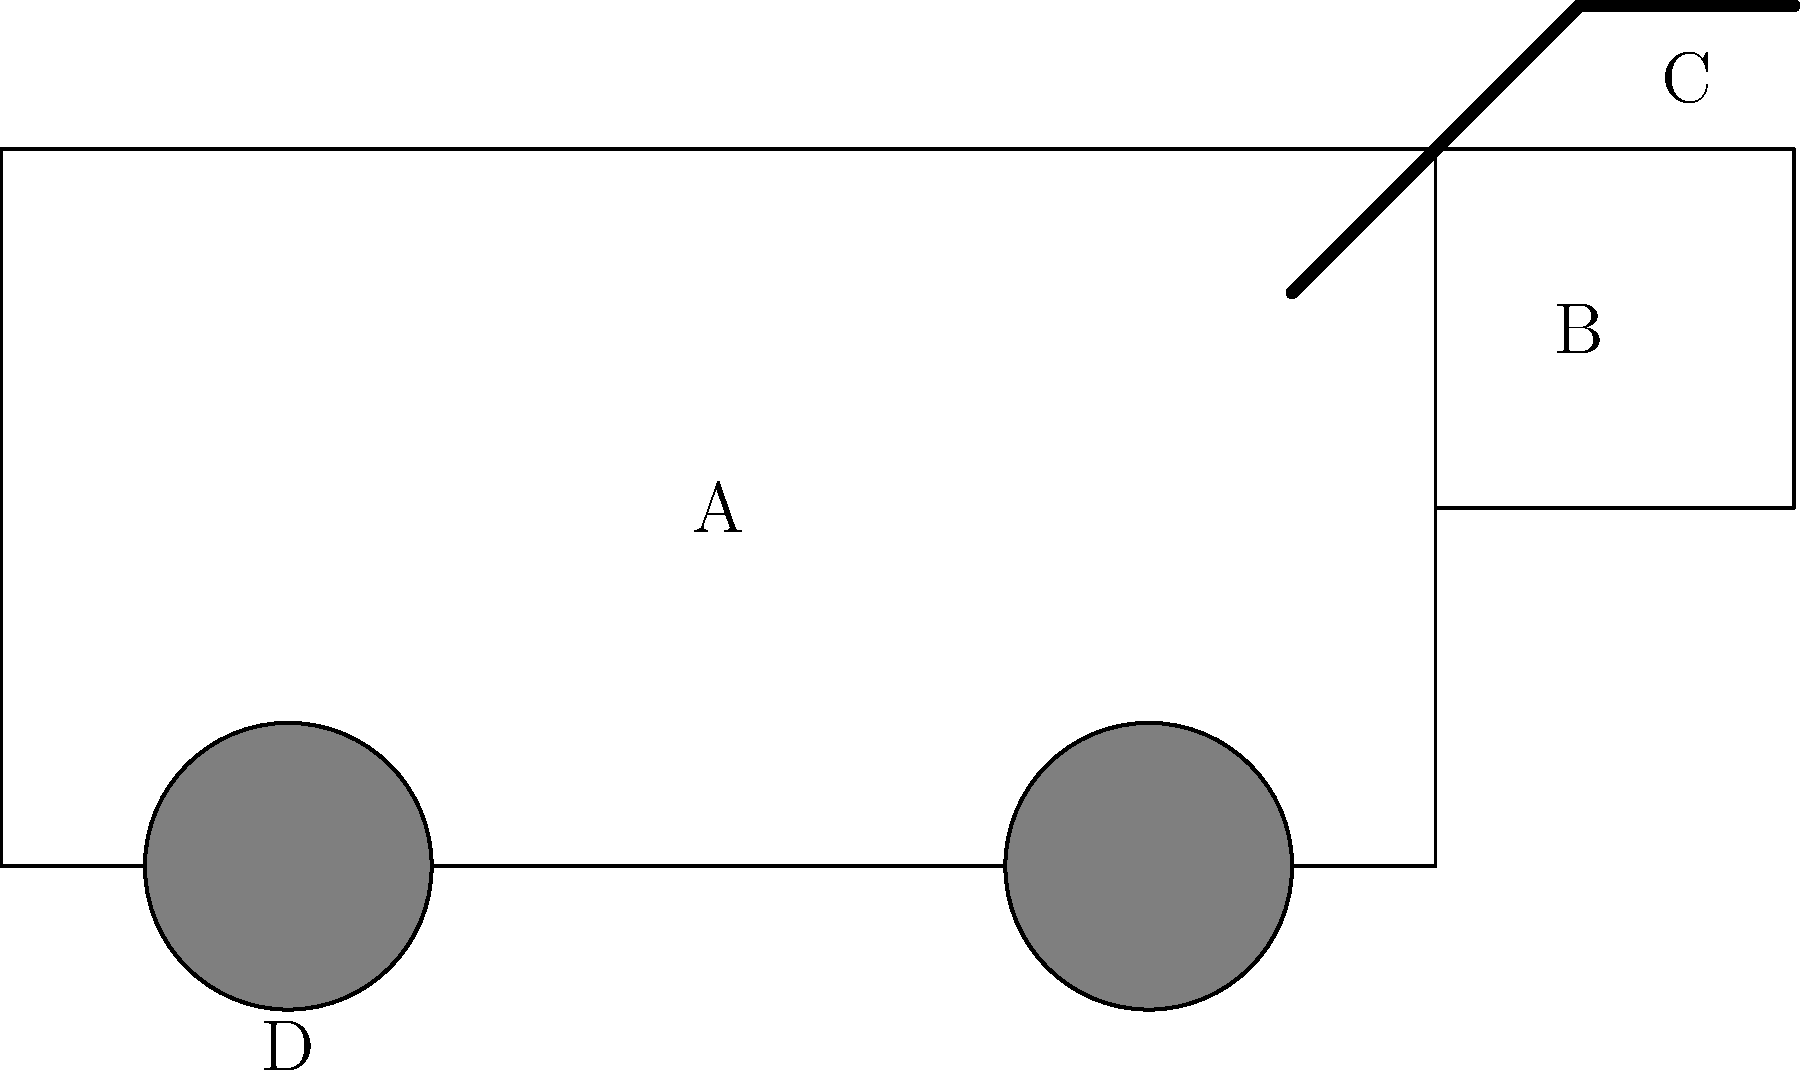In the diagram of a garbage truck, what does label "C" represent? Let's examine the different parts of the garbage truck in the diagram:

1. The main body of the truck is represented by the large rectangular shape.
2. Label "A" is in the center of this body, likely representing the cab or main compartment.
3. Label "B" is on the rear section of the truck, which appears to be the hopper where garbage is initially loaded.
4. Label "C" is at the top of a movable arm-like structure at the back of the truck.
5. Label "D" is below one of the wheels.

Given your experience as a garbage collector, you would recognize that the arm-like structure at the back of the truck is used to lift and empty garbage containers into the hopper. This mechanism is known as the hydraulic arm or lifting mechanism.

Therefore, label "C" represents the hydraulic arm or lifting mechanism of the garbage truck.
Answer: Hydraulic arm 